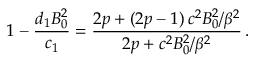<formula> <loc_0><loc_0><loc_500><loc_500>1 - \frac { d _ { 1 } B _ { 0 } ^ { 2 } } { c _ { 1 } } = \frac { 2 p + ( 2 p - 1 ) \, c ^ { 2 } B _ { 0 } ^ { 2 } / \beta ^ { 2 } } { 2 p + c ^ { 2 } B _ { 0 } ^ { 2 } / \beta ^ { 2 } } \, .</formula> 